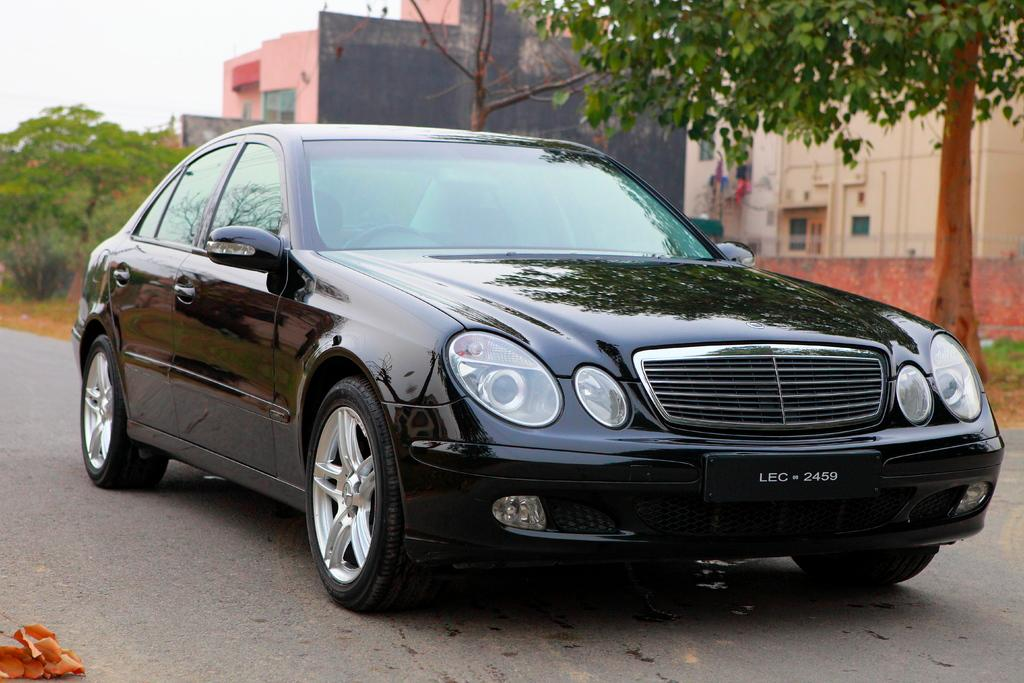What is in the foreground of the image? There is a road in the foreground of the image. What is on the road? There is a vehicle on the road. What can be seen in the background of the image? There are buildings and trees visible in the image. What is visible above the buildings and trees? The sky is visible in the image. Can you tell me what the toad and scarecrow are discussing in the image? There are no toads or scarecrows present in the image, so there is no discussion to be observed. 